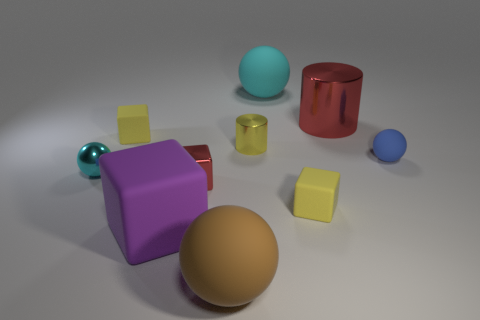Subtract all balls. How many objects are left? 6 Add 3 large red shiny things. How many large red shiny things are left? 4 Add 1 large green rubber balls. How many large green rubber balls exist? 1 Subtract 0 purple spheres. How many objects are left? 10 Subtract all small green rubber cubes. Subtract all big brown matte things. How many objects are left? 9 